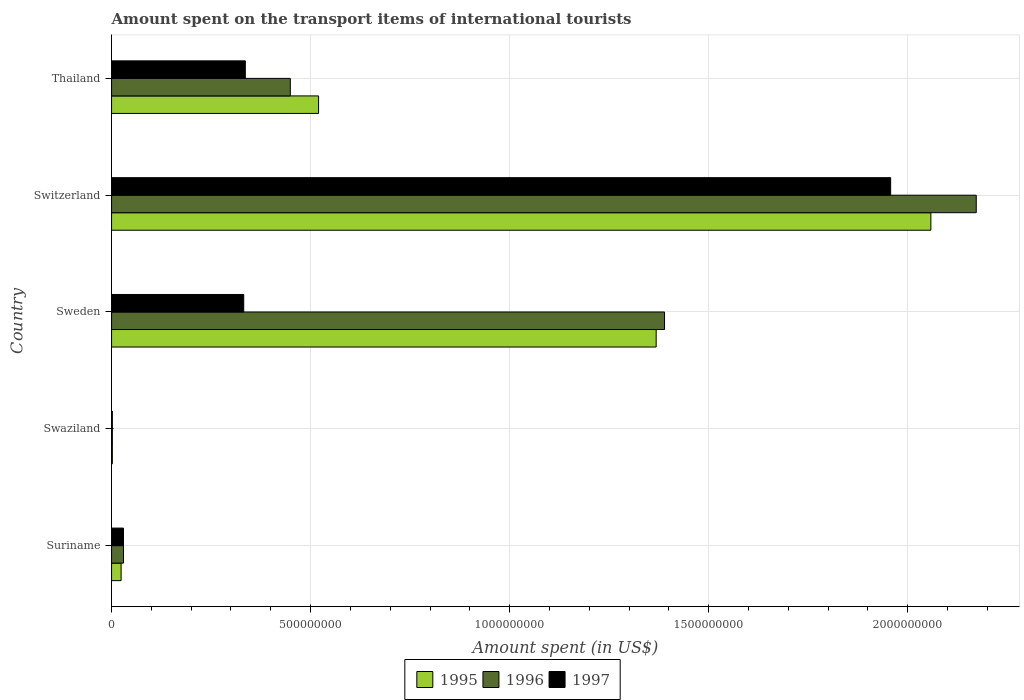How many different coloured bars are there?
Your answer should be compact. 3. Are the number of bars per tick equal to the number of legend labels?
Offer a terse response. Yes. How many bars are there on the 4th tick from the bottom?
Offer a very short reply. 3. What is the label of the 1st group of bars from the top?
Your answer should be very brief. Thailand. In how many cases, is the number of bars for a given country not equal to the number of legend labels?
Your answer should be very brief. 0. What is the amount spent on the transport items of international tourists in 1997 in Suriname?
Offer a terse response. 3.00e+07. Across all countries, what is the maximum amount spent on the transport items of international tourists in 1995?
Provide a succinct answer. 2.06e+09. Across all countries, what is the minimum amount spent on the transport items of international tourists in 1995?
Your answer should be compact. 2.00e+06. In which country was the amount spent on the transport items of international tourists in 1997 maximum?
Your answer should be compact. Switzerland. In which country was the amount spent on the transport items of international tourists in 1997 minimum?
Your response must be concise. Swaziland. What is the total amount spent on the transport items of international tourists in 1997 in the graph?
Your answer should be very brief. 2.66e+09. What is the difference between the amount spent on the transport items of international tourists in 1996 in Switzerland and that in Thailand?
Ensure brevity in your answer.  1.72e+09. What is the difference between the amount spent on the transport items of international tourists in 1995 in Suriname and the amount spent on the transport items of international tourists in 1996 in Switzerland?
Your answer should be compact. -2.15e+09. What is the average amount spent on the transport items of international tourists in 1995 per country?
Offer a terse response. 7.94e+08. What is the difference between the amount spent on the transport items of international tourists in 1996 and amount spent on the transport items of international tourists in 1997 in Swaziland?
Your answer should be very brief. 0. In how many countries, is the amount spent on the transport items of international tourists in 1997 greater than 800000000 US$?
Ensure brevity in your answer.  1. What is the ratio of the amount spent on the transport items of international tourists in 1997 in Swaziland to that in Thailand?
Your answer should be very brief. 0.01. Is the amount spent on the transport items of international tourists in 1996 in Switzerland less than that in Thailand?
Ensure brevity in your answer.  No. Is the difference between the amount spent on the transport items of international tourists in 1996 in Switzerland and Thailand greater than the difference between the amount spent on the transport items of international tourists in 1997 in Switzerland and Thailand?
Provide a short and direct response. Yes. What is the difference between the highest and the second highest amount spent on the transport items of international tourists in 1997?
Your answer should be compact. 1.62e+09. What is the difference between the highest and the lowest amount spent on the transport items of international tourists in 1997?
Give a very brief answer. 1.96e+09. What does the 2nd bar from the top in Swaziland represents?
Keep it short and to the point. 1996. Is it the case that in every country, the sum of the amount spent on the transport items of international tourists in 1995 and amount spent on the transport items of international tourists in 1996 is greater than the amount spent on the transport items of international tourists in 1997?
Your answer should be compact. Yes. How many bars are there?
Offer a very short reply. 15. Are all the bars in the graph horizontal?
Offer a very short reply. Yes. What is the difference between two consecutive major ticks on the X-axis?
Your answer should be very brief. 5.00e+08. Are the values on the major ticks of X-axis written in scientific E-notation?
Offer a very short reply. No. Does the graph contain any zero values?
Your answer should be compact. No. How are the legend labels stacked?
Your answer should be very brief. Horizontal. What is the title of the graph?
Provide a short and direct response. Amount spent on the transport items of international tourists. What is the label or title of the X-axis?
Ensure brevity in your answer.  Amount spent (in US$). What is the Amount spent (in US$) in 1995 in Suriname?
Offer a very short reply. 2.40e+07. What is the Amount spent (in US$) of 1996 in Suriname?
Offer a very short reply. 3.00e+07. What is the Amount spent (in US$) of 1997 in Suriname?
Offer a very short reply. 3.00e+07. What is the Amount spent (in US$) of 1996 in Swaziland?
Keep it short and to the point. 2.00e+06. What is the Amount spent (in US$) in 1997 in Swaziland?
Offer a very short reply. 2.00e+06. What is the Amount spent (in US$) in 1995 in Sweden?
Your response must be concise. 1.37e+09. What is the Amount spent (in US$) in 1996 in Sweden?
Offer a very short reply. 1.39e+09. What is the Amount spent (in US$) in 1997 in Sweden?
Offer a terse response. 3.32e+08. What is the Amount spent (in US$) of 1995 in Switzerland?
Offer a very short reply. 2.06e+09. What is the Amount spent (in US$) in 1996 in Switzerland?
Provide a succinct answer. 2.17e+09. What is the Amount spent (in US$) of 1997 in Switzerland?
Give a very brief answer. 1.96e+09. What is the Amount spent (in US$) in 1995 in Thailand?
Give a very brief answer. 5.20e+08. What is the Amount spent (in US$) of 1996 in Thailand?
Offer a terse response. 4.49e+08. What is the Amount spent (in US$) of 1997 in Thailand?
Keep it short and to the point. 3.36e+08. Across all countries, what is the maximum Amount spent (in US$) of 1995?
Offer a terse response. 2.06e+09. Across all countries, what is the maximum Amount spent (in US$) of 1996?
Offer a very short reply. 2.17e+09. Across all countries, what is the maximum Amount spent (in US$) in 1997?
Give a very brief answer. 1.96e+09. Across all countries, what is the minimum Amount spent (in US$) of 1995?
Offer a terse response. 2.00e+06. Across all countries, what is the minimum Amount spent (in US$) of 1996?
Keep it short and to the point. 2.00e+06. What is the total Amount spent (in US$) of 1995 in the graph?
Your answer should be very brief. 3.97e+09. What is the total Amount spent (in US$) in 1996 in the graph?
Keep it short and to the point. 4.04e+09. What is the total Amount spent (in US$) of 1997 in the graph?
Make the answer very short. 2.66e+09. What is the difference between the Amount spent (in US$) of 1995 in Suriname and that in Swaziland?
Keep it short and to the point. 2.20e+07. What is the difference between the Amount spent (in US$) in 1996 in Suriname and that in Swaziland?
Your answer should be compact. 2.80e+07. What is the difference between the Amount spent (in US$) of 1997 in Suriname and that in Swaziland?
Keep it short and to the point. 2.80e+07. What is the difference between the Amount spent (in US$) of 1995 in Suriname and that in Sweden?
Your response must be concise. -1.34e+09. What is the difference between the Amount spent (in US$) of 1996 in Suriname and that in Sweden?
Give a very brief answer. -1.36e+09. What is the difference between the Amount spent (in US$) in 1997 in Suriname and that in Sweden?
Your answer should be very brief. -3.02e+08. What is the difference between the Amount spent (in US$) in 1995 in Suriname and that in Switzerland?
Offer a very short reply. -2.03e+09. What is the difference between the Amount spent (in US$) in 1996 in Suriname and that in Switzerland?
Provide a short and direct response. -2.14e+09. What is the difference between the Amount spent (in US$) in 1997 in Suriname and that in Switzerland?
Give a very brief answer. -1.93e+09. What is the difference between the Amount spent (in US$) in 1995 in Suriname and that in Thailand?
Offer a terse response. -4.96e+08. What is the difference between the Amount spent (in US$) of 1996 in Suriname and that in Thailand?
Give a very brief answer. -4.19e+08. What is the difference between the Amount spent (in US$) in 1997 in Suriname and that in Thailand?
Provide a succinct answer. -3.06e+08. What is the difference between the Amount spent (in US$) in 1995 in Swaziland and that in Sweden?
Give a very brief answer. -1.37e+09. What is the difference between the Amount spent (in US$) of 1996 in Swaziland and that in Sweden?
Your answer should be very brief. -1.39e+09. What is the difference between the Amount spent (in US$) of 1997 in Swaziland and that in Sweden?
Provide a succinct answer. -3.30e+08. What is the difference between the Amount spent (in US$) in 1995 in Swaziland and that in Switzerland?
Ensure brevity in your answer.  -2.06e+09. What is the difference between the Amount spent (in US$) in 1996 in Swaziland and that in Switzerland?
Your answer should be very brief. -2.17e+09. What is the difference between the Amount spent (in US$) in 1997 in Swaziland and that in Switzerland?
Provide a short and direct response. -1.96e+09. What is the difference between the Amount spent (in US$) in 1995 in Swaziland and that in Thailand?
Your response must be concise. -5.18e+08. What is the difference between the Amount spent (in US$) in 1996 in Swaziland and that in Thailand?
Offer a terse response. -4.47e+08. What is the difference between the Amount spent (in US$) of 1997 in Swaziland and that in Thailand?
Give a very brief answer. -3.34e+08. What is the difference between the Amount spent (in US$) in 1995 in Sweden and that in Switzerland?
Keep it short and to the point. -6.90e+08. What is the difference between the Amount spent (in US$) in 1996 in Sweden and that in Switzerland?
Provide a succinct answer. -7.83e+08. What is the difference between the Amount spent (in US$) of 1997 in Sweden and that in Switzerland?
Offer a very short reply. -1.62e+09. What is the difference between the Amount spent (in US$) of 1995 in Sweden and that in Thailand?
Give a very brief answer. 8.48e+08. What is the difference between the Amount spent (in US$) of 1996 in Sweden and that in Thailand?
Keep it short and to the point. 9.40e+08. What is the difference between the Amount spent (in US$) of 1995 in Switzerland and that in Thailand?
Your answer should be compact. 1.54e+09. What is the difference between the Amount spent (in US$) of 1996 in Switzerland and that in Thailand?
Offer a terse response. 1.72e+09. What is the difference between the Amount spent (in US$) in 1997 in Switzerland and that in Thailand?
Your response must be concise. 1.62e+09. What is the difference between the Amount spent (in US$) in 1995 in Suriname and the Amount spent (in US$) in 1996 in Swaziland?
Offer a terse response. 2.20e+07. What is the difference between the Amount spent (in US$) of 1995 in Suriname and the Amount spent (in US$) of 1997 in Swaziland?
Provide a short and direct response. 2.20e+07. What is the difference between the Amount spent (in US$) in 1996 in Suriname and the Amount spent (in US$) in 1997 in Swaziland?
Provide a succinct answer. 2.80e+07. What is the difference between the Amount spent (in US$) in 1995 in Suriname and the Amount spent (in US$) in 1996 in Sweden?
Make the answer very short. -1.36e+09. What is the difference between the Amount spent (in US$) of 1995 in Suriname and the Amount spent (in US$) of 1997 in Sweden?
Your answer should be compact. -3.08e+08. What is the difference between the Amount spent (in US$) of 1996 in Suriname and the Amount spent (in US$) of 1997 in Sweden?
Your response must be concise. -3.02e+08. What is the difference between the Amount spent (in US$) of 1995 in Suriname and the Amount spent (in US$) of 1996 in Switzerland?
Provide a short and direct response. -2.15e+09. What is the difference between the Amount spent (in US$) of 1995 in Suriname and the Amount spent (in US$) of 1997 in Switzerland?
Offer a very short reply. -1.93e+09. What is the difference between the Amount spent (in US$) in 1996 in Suriname and the Amount spent (in US$) in 1997 in Switzerland?
Keep it short and to the point. -1.93e+09. What is the difference between the Amount spent (in US$) of 1995 in Suriname and the Amount spent (in US$) of 1996 in Thailand?
Your answer should be compact. -4.25e+08. What is the difference between the Amount spent (in US$) in 1995 in Suriname and the Amount spent (in US$) in 1997 in Thailand?
Ensure brevity in your answer.  -3.12e+08. What is the difference between the Amount spent (in US$) of 1996 in Suriname and the Amount spent (in US$) of 1997 in Thailand?
Offer a very short reply. -3.06e+08. What is the difference between the Amount spent (in US$) in 1995 in Swaziland and the Amount spent (in US$) in 1996 in Sweden?
Keep it short and to the point. -1.39e+09. What is the difference between the Amount spent (in US$) in 1995 in Swaziland and the Amount spent (in US$) in 1997 in Sweden?
Provide a short and direct response. -3.30e+08. What is the difference between the Amount spent (in US$) in 1996 in Swaziland and the Amount spent (in US$) in 1997 in Sweden?
Make the answer very short. -3.30e+08. What is the difference between the Amount spent (in US$) in 1995 in Swaziland and the Amount spent (in US$) in 1996 in Switzerland?
Provide a short and direct response. -2.17e+09. What is the difference between the Amount spent (in US$) of 1995 in Swaziland and the Amount spent (in US$) of 1997 in Switzerland?
Your answer should be very brief. -1.96e+09. What is the difference between the Amount spent (in US$) in 1996 in Swaziland and the Amount spent (in US$) in 1997 in Switzerland?
Ensure brevity in your answer.  -1.96e+09. What is the difference between the Amount spent (in US$) of 1995 in Swaziland and the Amount spent (in US$) of 1996 in Thailand?
Your answer should be compact. -4.47e+08. What is the difference between the Amount spent (in US$) of 1995 in Swaziland and the Amount spent (in US$) of 1997 in Thailand?
Make the answer very short. -3.34e+08. What is the difference between the Amount spent (in US$) in 1996 in Swaziland and the Amount spent (in US$) in 1997 in Thailand?
Provide a succinct answer. -3.34e+08. What is the difference between the Amount spent (in US$) of 1995 in Sweden and the Amount spent (in US$) of 1996 in Switzerland?
Provide a succinct answer. -8.04e+08. What is the difference between the Amount spent (in US$) in 1995 in Sweden and the Amount spent (in US$) in 1997 in Switzerland?
Keep it short and to the point. -5.89e+08. What is the difference between the Amount spent (in US$) of 1996 in Sweden and the Amount spent (in US$) of 1997 in Switzerland?
Offer a very short reply. -5.68e+08. What is the difference between the Amount spent (in US$) of 1995 in Sweden and the Amount spent (in US$) of 1996 in Thailand?
Keep it short and to the point. 9.19e+08. What is the difference between the Amount spent (in US$) in 1995 in Sweden and the Amount spent (in US$) in 1997 in Thailand?
Offer a very short reply. 1.03e+09. What is the difference between the Amount spent (in US$) of 1996 in Sweden and the Amount spent (in US$) of 1997 in Thailand?
Offer a terse response. 1.05e+09. What is the difference between the Amount spent (in US$) in 1995 in Switzerland and the Amount spent (in US$) in 1996 in Thailand?
Keep it short and to the point. 1.61e+09. What is the difference between the Amount spent (in US$) of 1995 in Switzerland and the Amount spent (in US$) of 1997 in Thailand?
Offer a terse response. 1.72e+09. What is the difference between the Amount spent (in US$) in 1996 in Switzerland and the Amount spent (in US$) in 1997 in Thailand?
Offer a very short reply. 1.84e+09. What is the average Amount spent (in US$) in 1995 per country?
Give a very brief answer. 7.94e+08. What is the average Amount spent (in US$) of 1996 per country?
Your response must be concise. 8.08e+08. What is the average Amount spent (in US$) in 1997 per country?
Your answer should be very brief. 5.31e+08. What is the difference between the Amount spent (in US$) in 1995 and Amount spent (in US$) in 1996 in Suriname?
Provide a succinct answer. -6.00e+06. What is the difference between the Amount spent (in US$) of 1995 and Amount spent (in US$) of 1997 in Suriname?
Make the answer very short. -6.00e+06. What is the difference between the Amount spent (in US$) of 1996 and Amount spent (in US$) of 1997 in Suriname?
Keep it short and to the point. 0. What is the difference between the Amount spent (in US$) of 1995 and Amount spent (in US$) of 1996 in Sweden?
Your answer should be very brief. -2.10e+07. What is the difference between the Amount spent (in US$) of 1995 and Amount spent (in US$) of 1997 in Sweden?
Your answer should be very brief. 1.04e+09. What is the difference between the Amount spent (in US$) of 1996 and Amount spent (in US$) of 1997 in Sweden?
Offer a very short reply. 1.06e+09. What is the difference between the Amount spent (in US$) in 1995 and Amount spent (in US$) in 1996 in Switzerland?
Keep it short and to the point. -1.14e+08. What is the difference between the Amount spent (in US$) in 1995 and Amount spent (in US$) in 1997 in Switzerland?
Provide a short and direct response. 1.01e+08. What is the difference between the Amount spent (in US$) in 1996 and Amount spent (in US$) in 1997 in Switzerland?
Your answer should be compact. 2.15e+08. What is the difference between the Amount spent (in US$) in 1995 and Amount spent (in US$) in 1996 in Thailand?
Provide a succinct answer. 7.10e+07. What is the difference between the Amount spent (in US$) of 1995 and Amount spent (in US$) of 1997 in Thailand?
Keep it short and to the point. 1.84e+08. What is the difference between the Amount spent (in US$) of 1996 and Amount spent (in US$) of 1997 in Thailand?
Provide a succinct answer. 1.13e+08. What is the ratio of the Amount spent (in US$) in 1995 in Suriname to that in Swaziland?
Provide a short and direct response. 12. What is the ratio of the Amount spent (in US$) in 1996 in Suriname to that in Swaziland?
Provide a succinct answer. 15. What is the ratio of the Amount spent (in US$) in 1997 in Suriname to that in Swaziland?
Provide a succinct answer. 15. What is the ratio of the Amount spent (in US$) in 1995 in Suriname to that in Sweden?
Your answer should be very brief. 0.02. What is the ratio of the Amount spent (in US$) in 1996 in Suriname to that in Sweden?
Make the answer very short. 0.02. What is the ratio of the Amount spent (in US$) in 1997 in Suriname to that in Sweden?
Your answer should be very brief. 0.09. What is the ratio of the Amount spent (in US$) in 1995 in Suriname to that in Switzerland?
Make the answer very short. 0.01. What is the ratio of the Amount spent (in US$) in 1996 in Suriname to that in Switzerland?
Give a very brief answer. 0.01. What is the ratio of the Amount spent (in US$) of 1997 in Suriname to that in Switzerland?
Offer a very short reply. 0.02. What is the ratio of the Amount spent (in US$) of 1995 in Suriname to that in Thailand?
Provide a succinct answer. 0.05. What is the ratio of the Amount spent (in US$) in 1996 in Suriname to that in Thailand?
Your answer should be compact. 0.07. What is the ratio of the Amount spent (in US$) in 1997 in Suriname to that in Thailand?
Offer a terse response. 0.09. What is the ratio of the Amount spent (in US$) of 1995 in Swaziland to that in Sweden?
Keep it short and to the point. 0. What is the ratio of the Amount spent (in US$) in 1996 in Swaziland to that in Sweden?
Keep it short and to the point. 0. What is the ratio of the Amount spent (in US$) of 1997 in Swaziland to that in Sweden?
Offer a terse response. 0.01. What is the ratio of the Amount spent (in US$) of 1995 in Swaziland to that in Switzerland?
Provide a succinct answer. 0. What is the ratio of the Amount spent (in US$) of 1996 in Swaziland to that in Switzerland?
Offer a very short reply. 0. What is the ratio of the Amount spent (in US$) of 1997 in Swaziland to that in Switzerland?
Give a very brief answer. 0. What is the ratio of the Amount spent (in US$) in 1995 in Swaziland to that in Thailand?
Your answer should be very brief. 0. What is the ratio of the Amount spent (in US$) in 1996 in Swaziland to that in Thailand?
Ensure brevity in your answer.  0. What is the ratio of the Amount spent (in US$) of 1997 in Swaziland to that in Thailand?
Give a very brief answer. 0.01. What is the ratio of the Amount spent (in US$) in 1995 in Sweden to that in Switzerland?
Keep it short and to the point. 0.66. What is the ratio of the Amount spent (in US$) in 1996 in Sweden to that in Switzerland?
Your answer should be very brief. 0.64. What is the ratio of the Amount spent (in US$) in 1997 in Sweden to that in Switzerland?
Offer a very short reply. 0.17. What is the ratio of the Amount spent (in US$) of 1995 in Sweden to that in Thailand?
Provide a short and direct response. 2.63. What is the ratio of the Amount spent (in US$) of 1996 in Sweden to that in Thailand?
Your response must be concise. 3.09. What is the ratio of the Amount spent (in US$) of 1995 in Switzerland to that in Thailand?
Give a very brief answer. 3.96. What is the ratio of the Amount spent (in US$) of 1996 in Switzerland to that in Thailand?
Provide a succinct answer. 4.84. What is the ratio of the Amount spent (in US$) of 1997 in Switzerland to that in Thailand?
Provide a short and direct response. 5.82. What is the difference between the highest and the second highest Amount spent (in US$) of 1995?
Your answer should be very brief. 6.90e+08. What is the difference between the highest and the second highest Amount spent (in US$) of 1996?
Provide a short and direct response. 7.83e+08. What is the difference between the highest and the second highest Amount spent (in US$) of 1997?
Your answer should be compact. 1.62e+09. What is the difference between the highest and the lowest Amount spent (in US$) in 1995?
Give a very brief answer. 2.06e+09. What is the difference between the highest and the lowest Amount spent (in US$) of 1996?
Give a very brief answer. 2.17e+09. What is the difference between the highest and the lowest Amount spent (in US$) of 1997?
Keep it short and to the point. 1.96e+09. 